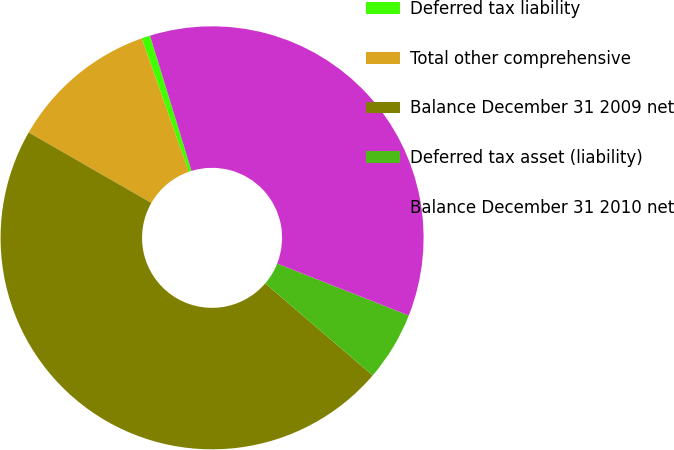Convert chart to OTSL. <chart><loc_0><loc_0><loc_500><loc_500><pie_chart><fcel>Deferred tax liability<fcel>Total other comprehensive<fcel>Balance December 31 2009 net<fcel>Deferred tax asset (liability)<fcel>Balance December 31 2010 net<nl><fcel>0.66%<fcel>11.3%<fcel>47.02%<fcel>5.29%<fcel>35.72%<nl></chart> 